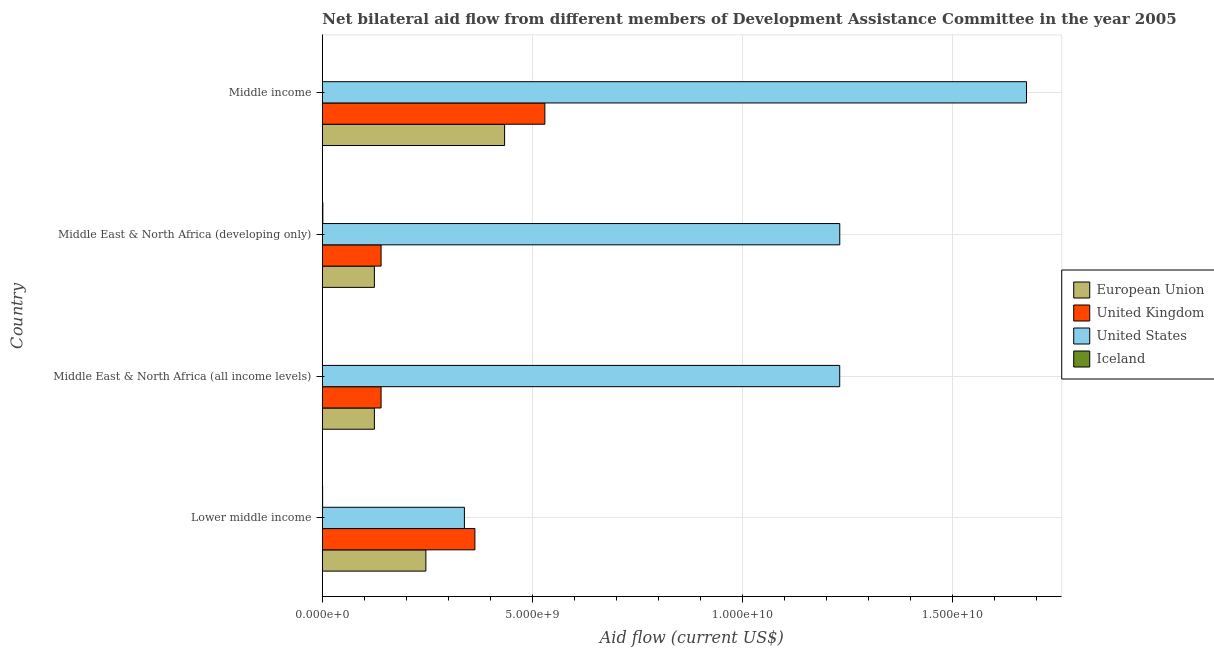How many different coloured bars are there?
Keep it short and to the point. 4. How many groups of bars are there?
Your answer should be compact. 4. Are the number of bars on each tick of the Y-axis equal?
Keep it short and to the point. Yes. How many bars are there on the 3rd tick from the top?
Your answer should be compact. 4. What is the label of the 2nd group of bars from the top?
Your answer should be compact. Middle East & North Africa (developing only). In how many cases, is the number of bars for a given country not equal to the number of legend labels?
Your response must be concise. 0. What is the amount of aid given by iceland in Middle East & North Africa (developing only)?
Provide a short and direct response. 1.24e+07. Across all countries, what is the maximum amount of aid given by eu?
Offer a terse response. 4.34e+09. Across all countries, what is the minimum amount of aid given by us?
Your answer should be very brief. 3.38e+09. In which country was the amount of aid given by us minimum?
Your answer should be very brief. Lower middle income. What is the total amount of aid given by iceland in the graph?
Ensure brevity in your answer.  2.49e+07. What is the difference between the amount of aid given by iceland in Lower middle income and that in Middle income?
Provide a succinct answer. 3.99e+06. What is the difference between the amount of aid given by iceland in Middle East & North Africa (all income levels) and the amount of aid given by us in Lower middle income?
Your answer should be very brief. -3.38e+09. What is the average amount of aid given by iceland per country?
Your answer should be very brief. 6.22e+06. What is the difference between the amount of aid given by us and amount of aid given by uk in Middle income?
Your answer should be compact. 1.15e+1. In how many countries, is the amount of aid given by uk greater than 4000000000 US$?
Make the answer very short. 1. Is the amount of aid given by eu in Lower middle income less than that in Middle income?
Offer a very short reply. Yes. Is the difference between the amount of aid given by eu in Lower middle income and Middle East & North Africa (all income levels) greater than the difference between the amount of aid given by us in Lower middle income and Middle East & North Africa (all income levels)?
Provide a succinct answer. Yes. What is the difference between the highest and the second highest amount of aid given by uk?
Your answer should be very brief. 1.67e+09. What is the difference between the highest and the lowest amount of aid given by iceland?
Make the answer very short. 9.71e+06. Is the sum of the amount of aid given by eu in Middle East & North Africa (all income levels) and Middle East & North Africa (developing only) greater than the maximum amount of aid given by iceland across all countries?
Provide a short and direct response. Yes. Is it the case that in every country, the sum of the amount of aid given by eu and amount of aid given by uk is greater than the amount of aid given by us?
Make the answer very short. No. How many bars are there?
Provide a succinct answer. 16. What is the difference between two consecutive major ticks on the X-axis?
Provide a succinct answer. 5.00e+09. Are the values on the major ticks of X-axis written in scientific E-notation?
Offer a very short reply. Yes. Does the graph contain grids?
Provide a succinct answer. Yes. Where does the legend appear in the graph?
Your response must be concise. Center right. How many legend labels are there?
Keep it short and to the point. 4. What is the title of the graph?
Offer a terse response. Net bilateral aid flow from different members of Development Assistance Committee in the year 2005. What is the label or title of the Y-axis?
Offer a terse response. Country. What is the Aid flow (current US$) in European Union in Lower middle income?
Keep it short and to the point. 2.46e+09. What is the Aid flow (current US$) of United Kingdom in Lower middle income?
Give a very brief answer. 3.63e+09. What is the Aid flow (current US$) of United States in Lower middle income?
Your response must be concise. 3.38e+09. What is the Aid flow (current US$) of Iceland in Lower middle income?
Offer a very short reply. 6.90e+06. What is the Aid flow (current US$) of European Union in Middle East & North Africa (all income levels)?
Your response must be concise. 1.24e+09. What is the Aid flow (current US$) of United Kingdom in Middle East & North Africa (all income levels)?
Provide a succinct answer. 1.40e+09. What is the Aid flow (current US$) of United States in Middle East & North Africa (all income levels)?
Your answer should be very brief. 1.23e+1. What is the Aid flow (current US$) in Iceland in Middle East & North Africa (all income levels)?
Make the answer very short. 2.68e+06. What is the Aid flow (current US$) in European Union in Middle East & North Africa (developing only)?
Your answer should be compact. 1.24e+09. What is the Aid flow (current US$) of United Kingdom in Middle East & North Africa (developing only)?
Make the answer very short. 1.40e+09. What is the Aid flow (current US$) of United States in Middle East & North Africa (developing only)?
Keep it short and to the point. 1.23e+1. What is the Aid flow (current US$) of Iceland in Middle East & North Africa (developing only)?
Make the answer very short. 1.24e+07. What is the Aid flow (current US$) of European Union in Middle income?
Provide a succinct answer. 4.34e+09. What is the Aid flow (current US$) of United Kingdom in Middle income?
Your response must be concise. 5.30e+09. What is the Aid flow (current US$) of United States in Middle income?
Offer a terse response. 1.68e+1. What is the Aid flow (current US$) in Iceland in Middle income?
Make the answer very short. 2.91e+06. Across all countries, what is the maximum Aid flow (current US$) of European Union?
Offer a terse response. 4.34e+09. Across all countries, what is the maximum Aid flow (current US$) in United Kingdom?
Your response must be concise. 5.30e+09. Across all countries, what is the maximum Aid flow (current US$) in United States?
Provide a short and direct response. 1.68e+1. Across all countries, what is the maximum Aid flow (current US$) in Iceland?
Your answer should be compact. 1.24e+07. Across all countries, what is the minimum Aid flow (current US$) of European Union?
Your answer should be compact. 1.24e+09. Across all countries, what is the minimum Aid flow (current US$) of United Kingdom?
Your response must be concise. 1.40e+09. Across all countries, what is the minimum Aid flow (current US$) of United States?
Keep it short and to the point. 3.38e+09. Across all countries, what is the minimum Aid flow (current US$) of Iceland?
Provide a succinct answer. 2.68e+06. What is the total Aid flow (current US$) in European Union in the graph?
Keep it short and to the point. 9.28e+09. What is the total Aid flow (current US$) of United Kingdom in the graph?
Give a very brief answer. 1.17e+1. What is the total Aid flow (current US$) of United States in the graph?
Your response must be concise. 4.48e+1. What is the total Aid flow (current US$) of Iceland in the graph?
Your response must be concise. 2.49e+07. What is the difference between the Aid flow (current US$) in European Union in Lower middle income and that in Middle East & North Africa (all income levels)?
Offer a terse response. 1.23e+09. What is the difference between the Aid flow (current US$) of United Kingdom in Lower middle income and that in Middle East & North Africa (all income levels)?
Your response must be concise. 2.23e+09. What is the difference between the Aid flow (current US$) of United States in Lower middle income and that in Middle East & North Africa (all income levels)?
Your answer should be very brief. -8.93e+09. What is the difference between the Aid flow (current US$) in Iceland in Lower middle income and that in Middle East & North Africa (all income levels)?
Provide a succinct answer. 4.22e+06. What is the difference between the Aid flow (current US$) in European Union in Lower middle income and that in Middle East & North Africa (developing only)?
Provide a succinct answer. 1.23e+09. What is the difference between the Aid flow (current US$) of United Kingdom in Lower middle income and that in Middle East & North Africa (developing only)?
Your response must be concise. 2.23e+09. What is the difference between the Aid flow (current US$) in United States in Lower middle income and that in Middle East & North Africa (developing only)?
Your answer should be very brief. -8.94e+09. What is the difference between the Aid flow (current US$) of Iceland in Lower middle income and that in Middle East & North Africa (developing only)?
Provide a short and direct response. -5.49e+06. What is the difference between the Aid flow (current US$) of European Union in Lower middle income and that in Middle income?
Offer a very short reply. -1.87e+09. What is the difference between the Aid flow (current US$) of United Kingdom in Lower middle income and that in Middle income?
Make the answer very short. -1.67e+09. What is the difference between the Aid flow (current US$) of United States in Lower middle income and that in Middle income?
Ensure brevity in your answer.  -1.34e+1. What is the difference between the Aid flow (current US$) of Iceland in Lower middle income and that in Middle income?
Your answer should be very brief. 3.99e+06. What is the difference between the Aid flow (current US$) in United Kingdom in Middle East & North Africa (all income levels) and that in Middle East & North Africa (developing only)?
Your response must be concise. 0. What is the difference between the Aid flow (current US$) in United States in Middle East & North Africa (all income levels) and that in Middle East & North Africa (developing only)?
Your response must be concise. -1.02e+06. What is the difference between the Aid flow (current US$) in Iceland in Middle East & North Africa (all income levels) and that in Middle East & North Africa (developing only)?
Give a very brief answer. -9.71e+06. What is the difference between the Aid flow (current US$) in European Union in Middle East & North Africa (all income levels) and that in Middle income?
Your response must be concise. -3.10e+09. What is the difference between the Aid flow (current US$) of United Kingdom in Middle East & North Africa (all income levels) and that in Middle income?
Make the answer very short. -3.90e+09. What is the difference between the Aid flow (current US$) of United States in Middle East & North Africa (all income levels) and that in Middle income?
Provide a succinct answer. -4.45e+09. What is the difference between the Aid flow (current US$) in Iceland in Middle East & North Africa (all income levels) and that in Middle income?
Ensure brevity in your answer.  -2.30e+05. What is the difference between the Aid flow (current US$) of European Union in Middle East & North Africa (developing only) and that in Middle income?
Make the answer very short. -3.10e+09. What is the difference between the Aid flow (current US$) of United Kingdom in Middle East & North Africa (developing only) and that in Middle income?
Make the answer very short. -3.90e+09. What is the difference between the Aid flow (current US$) in United States in Middle East & North Africa (developing only) and that in Middle income?
Offer a terse response. -4.45e+09. What is the difference between the Aid flow (current US$) of Iceland in Middle East & North Africa (developing only) and that in Middle income?
Keep it short and to the point. 9.48e+06. What is the difference between the Aid flow (current US$) of European Union in Lower middle income and the Aid flow (current US$) of United Kingdom in Middle East & North Africa (all income levels)?
Provide a short and direct response. 1.07e+09. What is the difference between the Aid flow (current US$) of European Union in Lower middle income and the Aid flow (current US$) of United States in Middle East & North Africa (all income levels)?
Your response must be concise. -9.85e+09. What is the difference between the Aid flow (current US$) in European Union in Lower middle income and the Aid flow (current US$) in Iceland in Middle East & North Africa (all income levels)?
Provide a short and direct response. 2.46e+09. What is the difference between the Aid flow (current US$) of United Kingdom in Lower middle income and the Aid flow (current US$) of United States in Middle East & North Africa (all income levels)?
Your answer should be compact. -8.68e+09. What is the difference between the Aid flow (current US$) in United Kingdom in Lower middle income and the Aid flow (current US$) in Iceland in Middle East & North Africa (all income levels)?
Keep it short and to the point. 3.63e+09. What is the difference between the Aid flow (current US$) of United States in Lower middle income and the Aid flow (current US$) of Iceland in Middle East & North Africa (all income levels)?
Offer a terse response. 3.38e+09. What is the difference between the Aid flow (current US$) in European Union in Lower middle income and the Aid flow (current US$) in United Kingdom in Middle East & North Africa (developing only)?
Make the answer very short. 1.07e+09. What is the difference between the Aid flow (current US$) in European Union in Lower middle income and the Aid flow (current US$) in United States in Middle East & North Africa (developing only)?
Your answer should be very brief. -9.85e+09. What is the difference between the Aid flow (current US$) of European Union in Lower middle income and the Aid flow (current US$) of Iceland in Middle East & North Africa (developing only)?
Keep it short and to the point. 2.45e+09. What is the difference between the Aid flow (current US$) in United Kingdom in Lower middle income and the Aid flow (current US$) in United States in Middle East & North Africa (developing only)?
Offer a very short reply. -8.69e+09. What is the difference between the Aid flow (current US$) in United Kingdom in Lower middle income and the Aid flow (current US$) in Iceland in Middle East & North Africa (developing only)?
Provide a short and direct response. 3.62e+09. What is the difference between the Aid flow (current US$) of United States in Lower middle income and the Aid flow (current US$) of Iceland in Middle East & North Africa (developing only)?
Make the answer very short. 3.37e+09. What is the difference between the Aid flow (current US$) in European Union in Lower middle income and the Aid flow (current US$) in United Kingdom in Middle income?
Offer a very short reply. -2.83e+09. What is the difference between the Aid flow (current US$) of European Union in Lower middle income and the Aid flow (current US$) of United States in Middle income?
Make the answer very short. -1.43e+1. What is the difference between the Aid flow (current US$) of European Union in Lower middle income and the Aid flow (current US$) of Iceland in Middle income?
Your answer should be compact. 2.46e+09. What is the difference between the Aid flow (current US$) in United Kingdom in Lower middle income and the Aid flow (current US$) in United States in Middle income?
Provide a short and direct response. -1.31e+1. What is the difference between the Aid flow (current US$) of United Kingdom in Lower middle income and the Aid flow (current US$) of Iceland in Middle income?
Provide a short and direct response. 3.63e+09. What is the difference between the Aid flow (current US$) of United States in Lower middle income and the Aid flow (current US$) of Iceland in Middle income?
Offer a very short reply. 3.38e+09. What is the difference between the Aid flow (current US$) in European Union in Middle East & North Africa (all income levels) and the Aid flow (current US$) in United Kingdom in Middle East & North Africa (developing only)?
Your response must be concise. -1.59e+08. What is the difference between the Aid flow (current US$) of European Union in Middle East & North Africa (all income levels) and the Aid flow (current US$) of United States in Middle East & North Africa (developing only)?
Offer a terse response. -1.11e+1. What is the difference between the Aid flow (current US$) of European Union in Middle East & North Africa (all income levels) and the Aid flow (current US$) of Iceland in Middle East & North Africa (developing only)?
Keep it short and to the point. 1.23e+09. What is the difference between the Aid flow (current US$) of United Kingdom in Middle East & North Africa (all income levels) and the Aid flow (current US$) of United States in Middle East & North Africa (developing only)?
Give a very brief answer. -1.09e+1. What is the difference between the Aid flow (current US$) in United Kingdom in Middle East & North Africa (all income levels) and the Aid flow (current US$) in Iceland in Middle East & North Africa (developing only)?
Provide a succinct answer. 1.39e+09. What is the difference between the Aid flow (current US$) of United States in Middle East & North Africa (all income levels) and the Aid flow (current US$) of Iceland in Middle East & North Africa (developing only)?
Ensure brevity in your answer.  1.23e+1. What is the difference between the Aid flow (current US$) in European Union in Middle East & North Africa (all income levels) and the Aid flow (current US$) in United Kingdom in Middle income?
Ensure brevity in your answer.  -4.06e+09. What is the difference between the Aid flow (current US$) of European Union in Middle East & North Africa (all income levels) and the Aid flow (current US$) of United States in Middle income?
Provide a succinct answer. -1.55e+1. What is the difference between the Aid flow (current US$) in European Union in Middle East & North Africa (all income levels) and the Aid flow (current US$) in Iceland in Middle income?
Give a very brief answer. 1.24e+09. What is the difference between the Aid flow (current US$) of United Kingdom in Middle East & North Africa (all income levels) and the Aid flow (current US$) of United States in Middle income?
Your response must be concise. -1.54e+1. What is the difference between the Aid flow (current US$) in United Kingdom in Middle East & North Africa (all income levels) and the Aid flow (current US$) in Iceland in Middle income?
Provide a short and direct response. 1.40e+09. What is the difference between the Aid flow (current US$) in United States in Middle East & North Africa (all income levels) and the Aid flow (current US$) in Iceland in Middle income?
Ensure brevity in your answer.  1.23e+1. What is the difference between the Aid flow (current US$) of European Union in Middle East & North Africa (developing only) and the Aid flow (current US$) of United Kingdom in Middle income?
Make the answer very short. -4.06e+09. What is the difference between the Aid flow (current US$) of European Union in Middle East & North Africa (developing only) and the Aid flow (current US$) of United States in Middle income?
Your answer should be compact. -1.55e+1. What is the difference between the Aid flow (current US$) in European Union in Middle East & North Africa (developing only) and the Aid flow (current US$) in Iceland in Middle income?
Your answer should be compact. 1.24e+09. What is the difference between the Aid flow (current US$) of United Kingdom in Middle East & North Africa (developing only) and the Aid flow (current US$) of United States in Middle income?
Make the answer very short. -1.54e+1. What is the difference between the Aid flow (current US$) in United Kingdom in Middle East & North Africa (developing only) and the Aid flow (current US$) in Iceland in Middle income?
Provide a succinct answer. 1.40e+09. What is the difference between the Aid flow (current US$) in United States in Middle East & North Africa (developing only) and the Aid flow (current US$) in Iceland in Middle income?
Offer a very short reply. 1.23e+1. What is the average Aid flow (current US$) in European Union per country?
Ensure brevity in your answer.  2.32e+09. What is the average Aid flow (current US$) in United Kingdom per country?
Offer a terse response. 2.93e+09. What is the average Aid flow (current US$) in United States per country?
Give a very brief answer. 1.12e+1. What is the average Aid flow (current US$) of Iceland per country?
Your answer should be compact. 6.22e+06. What is the difference between the Aid flow (current US$) of European Union and Aid flow (current US$) of United Kingdom in Lower middle income?
Your response must be concise. -1.17e+09. What is the difference between the Aid flow (current US$) of European Union and Aid flow (current US$) of United States in Lower middle income?
Provide a short and direct response. -9.17e+08. What is the difference between the Aid flow (current US$) of European Union and Aid flow (current US$) of Iceland in Lower middle income?
Give a very brief answer. 2.46e+09. What is the difference between the Aid flow (current US$) of United Kingdom and Aid flow (current US$) of United States in Lower middle income?
Keep it short and to the point. 2.50e+08. What is the difference between the Aid flow (current US$) in United Kingdom and Aid flow (current US$) in Iceland in Lower middle income?
Your answer should be very brief. 3.63e+09. What is the difference between the Aid flow (current US$) in United States and Aid flow (current US$) in Iceland in Lower middle income?
Your answer should be compact. 3.38e+09. What is the difference between the Aid flow (current US$) in European Union and Aid flow (current US$) in United Kingdom in Middle East & North Africa (all income levels)?
Offer a terse response. -1.59e+08. What is the difference between the Aid flow (current US$) in European Union and Aid flow (current US$) in United States in Middle East & North Africa (all income levels)?
Offer a terse response. -1.11e+1. What is the difference between the Aid flow (current US$) in European Union and Aid flow (current US$) in Iceland in Middle East & North Africa (all income levels)?
Offer a terse response. 1.24e+09. What is the difference between the Aid flow (current US$) of United Kingdom and Aid flow (current US$) of United States in Middle East & North Africa (all income levels)?
Ensure brevity in your answer.  -1.09e+1. What is the difference between the Aid flow (current US$) of United Kingdom and Aid flow (current US$) of Iceland in Middle East & North Africa (all income levels)?
Your answer should be compact. 1.40e+09. What is the difference between the Aid flow (current US$) of United States and Aid flow (current US$) of Iceland in Middle East & North Africa (all income levels)?
Provide a succinct answer. 1.23e+1. What is the difference between the Aid flow (current US$) of European Union and Aid flow (current US$) of United Kingdom in Middle East & North Africa (developing only)?
Your answer should be compact. -1.59e+08. What is the difference between the Aid flow (current US$) of European Union and Aid flow (current US$) of United States in Middle East & North Africa (developing only)?
Your answer should be compact. -1.11e+1. What is the difference between the Aid flow (current US$) in European Union and Aid flow (current US$) in Iceland in Middle East & North Africa (developing only)?
Give a very brief answer. 1.23e+09. What is the difference between the Aid flow (current US$) of United Kingdom and Aid flow (current US$) of United States in Middle East & North Africa (developing only)?
Offer a very short reply. -1.09e+1. What is the difference between the Aid flow (current US$) in United Kingdom and Aid flow (current US$) in Iceland in Middle East & North Africa (developing only)?
Ensure brevity in your answer.  1.39e+09. What is the difference between the Aid flow (current US$) of United States and Aid flow (current US$) of Iceland in Middle East & North Africa (developing only)?
Your answer should be very brief. 1.23e+1. What is the difference between the Aid flow (current US$) in European Union and Aid flow (current US$) in United Kingdom in Middle income?
Give a very brief answer. -9.59e+08. What is the difference between the Aid flow (current US$) in European Union and Aid flow (current US$) in United States in Middle income?
Provide a short and direct response. -1.24e+1. What is the difference between the Aid flow (current US$) of European Union and Aid flow (current US$) of Iceland in Middle income?
Keep it short and to the point. 4.34e+09. What is the difference between the Aid flow (current US$) in United Kingdom and Aid flow (current US$) in United States in Middle income?
Your answer should be compact. -1.15e+1. What is the difference between the Aid flow (current US$) of United Kingdom and Aid flow (current US$) of Iceland in Middle income?
Offer a terse response. 5.29e+09. What is the difference between the Aid flow (current US$) of United States and Aid flow (current US$) of Iceland in Middle income?
Provide a short and direct response. 1.68e+1. What is the ratio of the Aid flow (current US$) of European Union in Lower middle income to that in Middle East & North Africa (all income levels)?
Keep it short and to the point. 1.99. What is the ratio of the Aid flow (current US$) in United Kingdom in Lower middle income to that in Middle East & North Africa (all income levels)?
Your answer should be very brief. 2.6. What is the ratio of the Aid flow (current US$) of United States in Lower middle income to that in Middle East & North Africa (all income levels)?
Keep it short and to the point. 0.27. What is the ratio of the Aid flow (current US$) in Iceland in Lower middle income to that in Middle East & North Africa (all income levels)?
Provide a succinct answer. 2.57. What is the ratio of the Aid flow (current US$) of European Union in Lower middle income to that in Middle East & North Africa (developing only)?
Ensure brevity in your answer.  1.99. What is the ratio of the Aid flow (current US$) in United Kingdom in Lower middle income to that in Middle East & North Africa (developing only)?
Offer a terse response. 2.6. What is the ratio of the Aid flow (current US$) in United States in Lower middle income to that in Middle East & North Africa (developing only)?
Make the answer very short. 0.27. What is the ratio of the Aid flow (current US$) of Iceland in Lower middle income to that in Middle East & North Africa (developing only)?
Give a very brief answer. 0.56. What is the ratio of the Aid flow (current US$) of European Union in Lower middle income to that in Middle income?
Provide a short and direct response. 0.57. What is the ratio of the Aid flow (current US$) of United Kingdom in Lower middle income to that in Middle income?
Offer a terse response. 0.69. What is the ratio of the Aid flow (current US$) of United States in Lower middle income to that in Middle income?
Your response must be concise. 0.2. What is the ratio of the Aid flow (current US$) in Iceland in Lower middle income to that in Middle income?
Your response must be concise. 2.37. What is the ratio of the Aid flow (current US$) in European Union in Middle East & North Africa (all income levels) to that in Middle East & North Africa (developing only)?
Provide a succinct answer. 1. What is the ratio of the Aid flow (current US$) of United Kingdom in Middle East & North Africa (all income levels) to that in Middle East & North Africa (developing only)?
Your answer should be compact. 1. What is the ratio of the Aid flow (current US$) of Iceland in Middle East & North Africa (all income levels) to that in Middle East & North Africa (developing only)?
Provide a succinct answer. 0.22. What is the ratio of the Aid flow (current US$) of European Union in Middle East & North Africa (all income levels) to that in Middle income?
Offer a very short reply. 0.29. What is the ratio of the Aid flow (current US$) in United Kingdom in Middle East & North Africa (all income levels) to that in Middle income?
Provide a succinct answer. 0.26. What is the ratio of the Aid flow (current US$) of United States in Middle East & North Africa (all income levels) to that in Middle income?
Offer a very short reply. 0.73. What is the ratio of the Aid flow (current US$) in Iceland in Middle East & North Africa (all income levels) to that in Middle income?
Your answer should be compact. 0.92. What is the ratio of the Aid flow (current US$) of European Union in Middle East & North Africa (developing only) to that in Middle income?
Your response must be concise. 0.29. What is the ratio of the Aid flow (current US$) in United Kingdom in Middle East & North Africa (developing only) to that in Middle income?
Keep it short and to the point. 0.26. What is the ratio of the Aid flow (current US$) in United States in Middle East & North Africa (developing only) to that in Middle income?
Offer a very short reply. 0.73. What is the ratio of the Aid flow (current US$) of Iceland in Middle East & North Africa (developing only) to that in Middle income?
Keep it short and to the point. 4.26. What is the difference between the highest and the second highest Aid flow (current US$) in European Union?
Offer a very short reply. 1.87e+09. What is the difference between the highest and the second highest Aid flow (current US$) of United Kingdom?
Offer a very short reply. 1.67e+09. What is the difference between the highest and the second highest Aid flow (current US$) of United States?
Your answer should be compact. 4.45e+09. What is the difference between the highest and the second highest Aid flow (current US$) of Iceland?
Make the answer very short. 5.49e+06. What is the difference between the highest and the lowest Aid flow (current US$) of European Union?
Your answer should be compact. 3.10e+09. What is the difference between the highest and the lowest Aid flow (current US$) in United Kingdom?
Provide a short and direct response. 3.90e+09. What is the difference between the highest and the lowest Aid flow (current US$) of United States?
Your answer should be very brief. 1.34e+1. What is the difference between the highest and the lowest Aid flow (current US$) in Iceland?
Keep it short and to the point. 9.71e+06. 